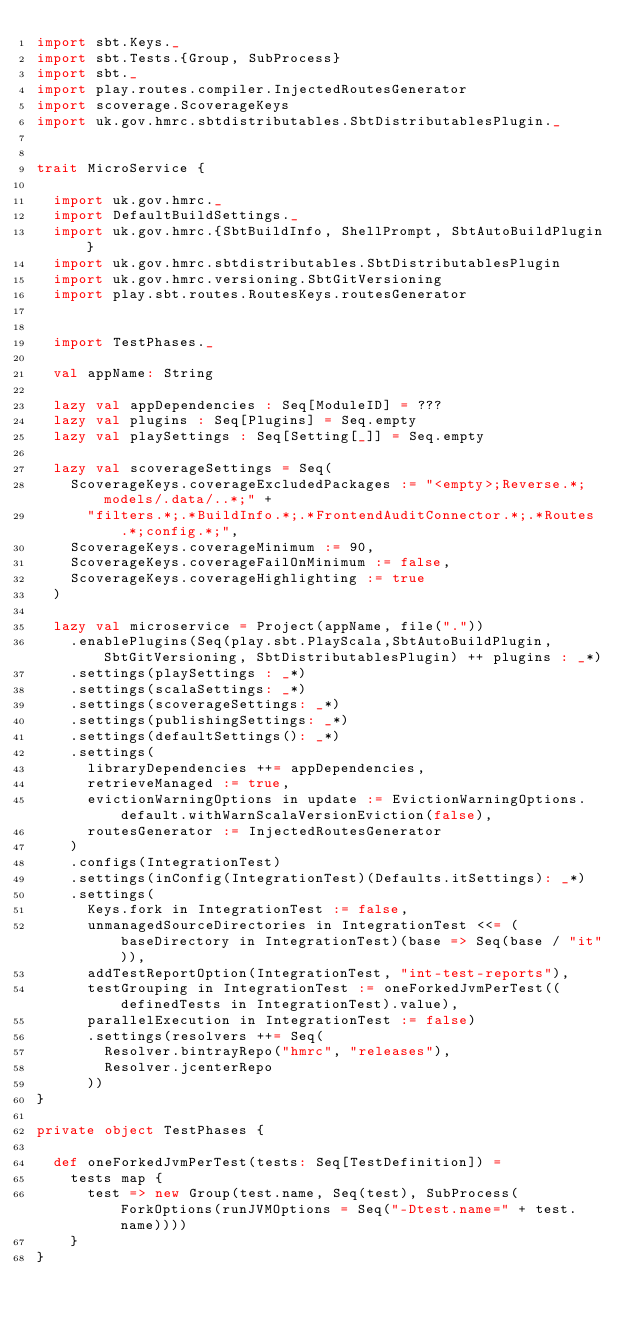<code> <loc_0><loc_0><loc_500><loc_500><_Scala_>import sbt.Keys._
import sbt.Tests.{Group, SubProcess}
import sbt._
import play.routes.compiler.InjectedRoutesGenerator
import scoverage.ScoverageKeys
import uk.gov.hmrc.sbtdistributables.SbtDistributablesPlugin._


trait MicroService {

  import uk.gov.hmrc._
  import DefaultBuildSettings._
  import uk.gov.hmrc.{SbtBuildInfo, ShellPrompt, SbtAutoBuildPlugin}
  import uk.gov.hmrc.sbtdistributables.SbtDistributablesPlugin
  import uk.gov.hmrc.versioning.SbtGitVersioning
  import play.sbt.routes.RoutesKeys.routesGenerator


  import TestPhases._

  val appName: String

  lazy val appDependencies : Seq[ModuleID] = ???
  lazy val plugins : Seq[Plugins] = Seq.empty
  lazy val playSettings : Seq[Setting[_]] = Seq.empty

  lazy val scoverageSettings = Seq(
    ScoverageKeys.coverageExcludedPackages := "<empty>;Reverse.*;models/.data/..*;" +
      "filters.*;.*BuildInfo.*;.*FrontendAuditConnector.*;.*Routes.*;config.*;",
    ScoverageKeys.coverageMinimum := 90,
    ScoverageKeys.coverageFailOnMinimum := false,
    ScoverageKeys.coverageHighlighting := true
  )

  lazy val microservice = Project(appName, file("."))
    .enablePlugins(Seq(play.sbt.PlayScala,SbtAutoBuildPlugin, SbtGitVersioning, SbtDistributablesPlugin) ++ plugins : _*)
    .settings(playSettings : _*)
    .settings(scalaSettings: _*)
    .settings(scoverageSettings: _*)
    .settings(publishingSettings: _*)
    .settings(defaultSettings(): _*)
    .settings(
      libraryDependencies ++= appDependencies,
      retrieveManaged := true,
      evictionWarningOptions in update := EvictionWarningOptions.default.withWarnScalaVersionEviction(false),
      routesGenerator := InjectedRoutesGenerator
    )
    .configs(IntegrationTest)
    .settings(inConfig(IntegrationTest)(Defaults.itSettings): _*)
    .settings(
      Keys.fork in IntegrationTest := false,
      unmanagedSourceDirectories in IntegrationTest <<= (baseDirectory in IntegrationTest)(base => Seq(base / "it")),
      addTestReportOption(IntegrationTest, "int-test-reports"),
      testGrouping in IntegrationTest := oneForkedJvmPerTest((definedTests in IntegrationTest).value),
      parallelExecution in IntegrationTest := false)
      .settings(resolvers ++= Seq(
        Resolver.bintrayRepo("hmrc", "releases"),
        Resolver.jcenterRepo
      ))
}

private object TestPhases {

  def oneForkedJvmPerTest(tests: Seq[TestDefinition]) =
    tests map {
      test => new Group(test.name, Seq(test), SubProcess(ForkOptions(runJVMOptions = Seq("-Dtest.name=" + test.name))))
    }
}
</code> 